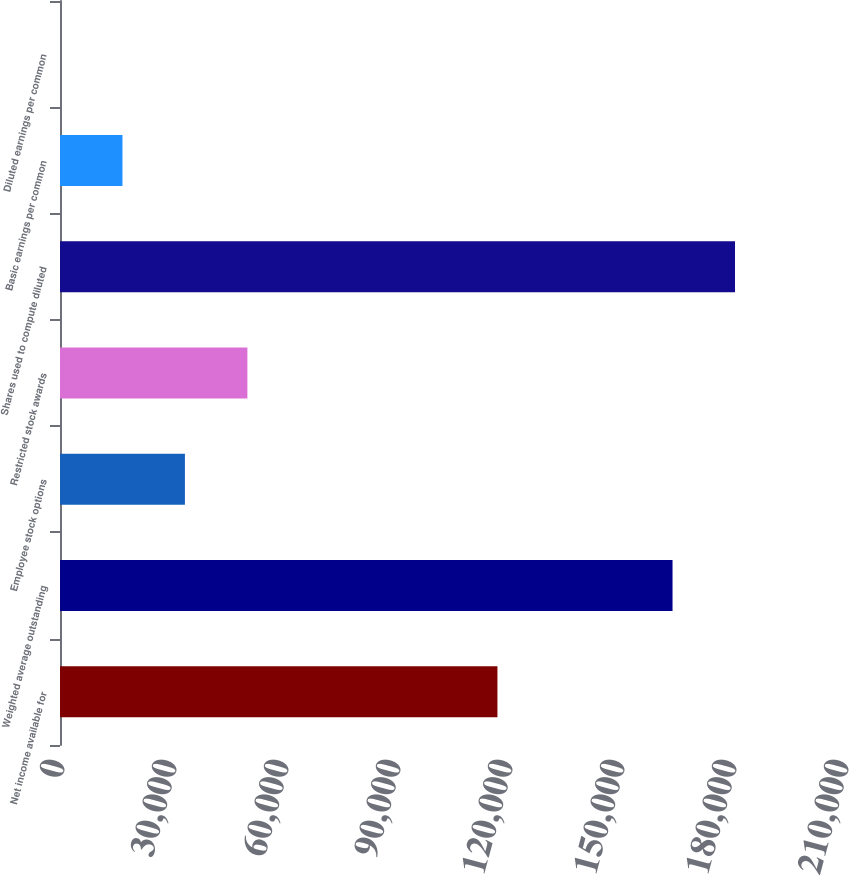Convert chart. <chart><loc_0><loc_0><loc_500><loc_500><bar_chart><fcel>Net income available for<fcel>Weighted average outstanding<fcel>Employee stock options<fcel>Restricted stock awards<fcel>Shares used to compute diluted<fcel>Basic earnings per common<fcel>Diluted earnings per common<nl><fcel>117171<fcel>164071<fcel>33462.2<fcel>50192.9<fcel>180802<fcel>16731.4<fcel>0.7<nl></chart> 